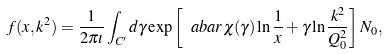<formula> <loc_0><loc_0><loc_500><loc_500>f ( x , k ^ { 2 } ) = \frac { 1 } { 2 \pi \imath } \int _ { C ^ { \prime } } d \gamma \exp \left [ \ a b a r \chi ( \gamma ) \ln \frac { 1 } { x } + \gamma \ln \frac { k ^ { 2 } } { Q _ { 0 } ^ { 2 } } \right ] N _ { 0 } ,</formula> 